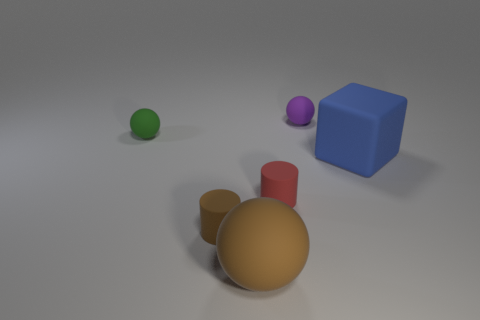How many objects are in total, and which one looks the largest? The image contains a total of five distinct objects: two cylinders, one sphere, one cube, and another smaller, sphere-like object. Of these, the blue cube visually appears to be the largest object due to its blocky, three-dimensional shape and prominent positioning in the image. 